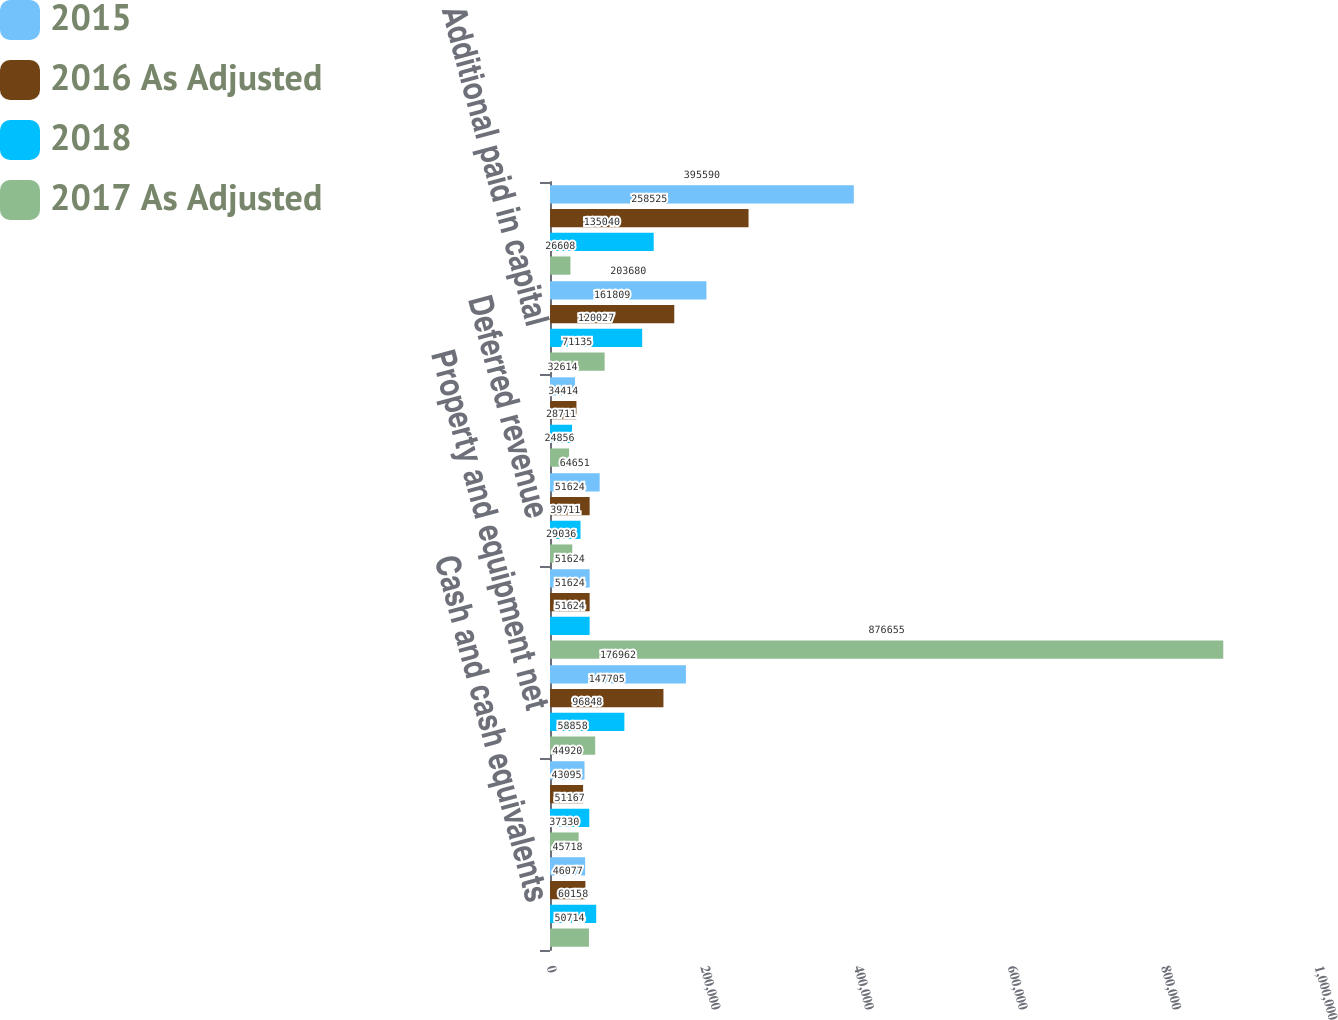<chart> <loc_0><loc_0><loc_500><loc_500><stacked_bar_chart><ecel><fcel>Cash and cash equivalents<fcel>Working capital 1<fcel>Property and equipment net<fcel>Total assets<fcel>Deferred revenue<fcel>Net long-term debt less<fcel>Additional paid in capital<fcel>Retained earnings<nl><fcel>2015<fcel>45718<fcel>44920<fcel>176962<fcel>51624<fcel>64651<fcel>32614<fcel>203680<fcel>395590<nl><fcel>2016 As Adjusted<fcel>46077<fcel>43095<fcel>147705<fcel>51624<fcel>51624<fcel>34414<fcel>161809<fcel>258525<nl><fcel>2018<fcel>60158<fcel>51167<fcel>96848<fcel>51624<fcel>39711<fcel>28711<fcel>120027<fcel>135040<nl><fcel>2017 As Adjusted<fcel>50714<fcel>37330<fcel>58858<fcel>876655<fcel>29036<fcel>24856<fcel>71135<fcel>26608<nl></chart> 